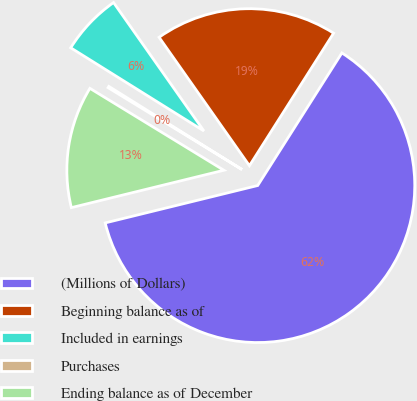Convert chart to OTSL. <chart><loc_0><loc_0><loc_500><loc_500><pie_chart><fcel>(Millions of Dollars)<fcel>Beginning balance as of<fcel>Included in earnings<fcel>Purchases<fcel>Ending balance as of December<nl><fcel>62.17%<fcel>18.76%<fcel>6.36%<fcel>0.15%<fcel>12.56%<nl></chart> 